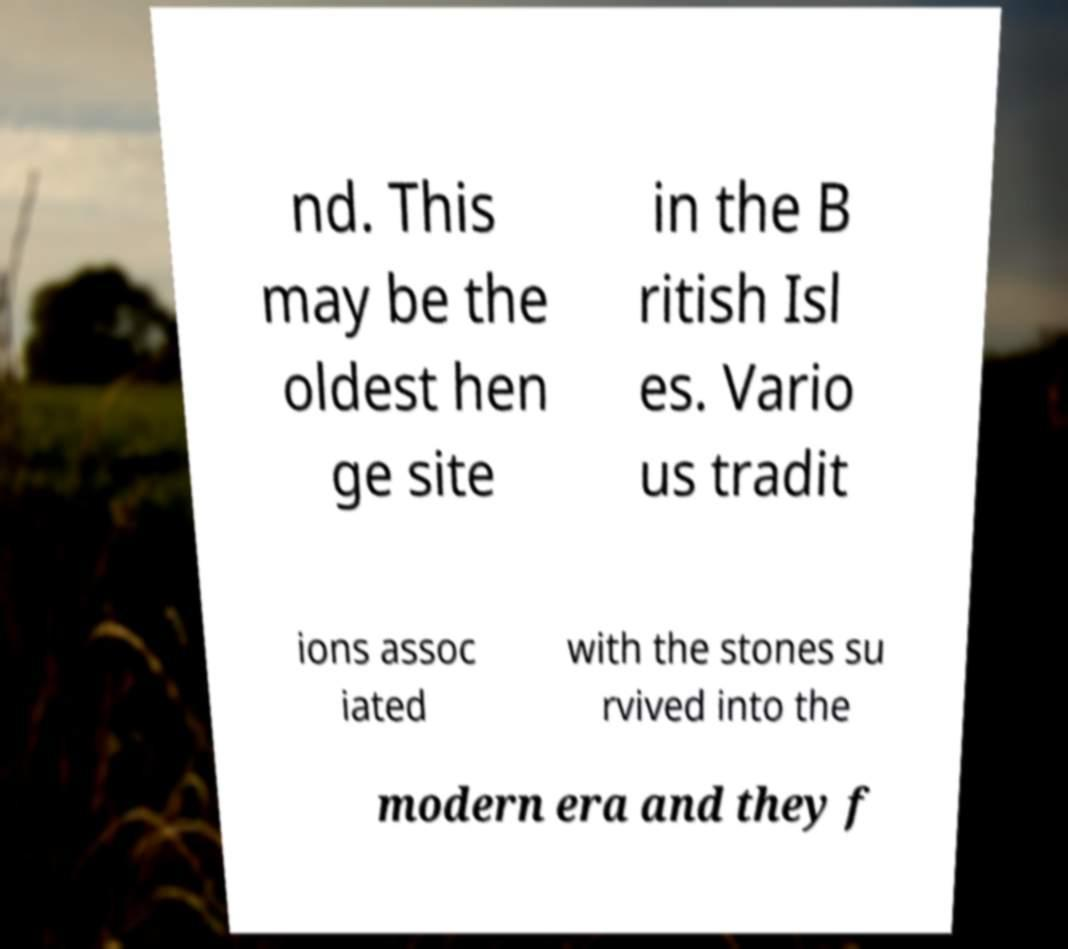For documentation purposes, I need the text within this image transcribed. Could you provide that? nd. This may be the oldest hen ge site in the B ritish Isl es. Vario us tradit ions assoc iated with the stones su rvived into the modern era and they f 